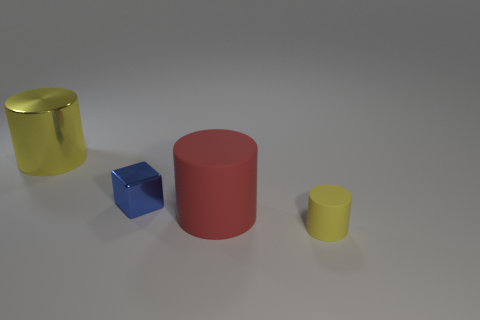Is the shape of the thing that is on the left side of the blue thing the same as the yellow thing in front of the large red object?
Make the answer very short. Yes. There is a large cylinder that is made of the same material as the tiny yellow cylinder; what is its color?
Provide a short and direct response. Red. There is a metallic object behind the tiny metallic thing; does it have the same size as the rubber object that is behind the tiny yellow object?
Your answer should be compact. Yes. What shape is the object that is in front of the big yellow metallic thing and to the left of the large matte cylinder?
Give a very brief answer. Cube. Are there any tiny purple cubes made of the same material as the red cylinder?
Offer a terse response. No. What material is the other object that is the same color as the big metallic object?
Your answer should be very brief. Rubber. Does the yellow object that is behind the large red rubber object have the same material as the small blue thing left of the big rubber cylinder?
Provide a succinct answer. Yes. Are there more red objects than red blocks?
Provide a short and direct response. Yes. There is a big thing to the right of the yellow metal cylinder that is behind the matte thing behind the yellow matte cylinder; what color is it?
Provide a succinct answer. Red. Does the rubber thing that is left of the small yellow object have the same color as the tiny object that is on the right side of the blue block?
Offer a terse response. No. 